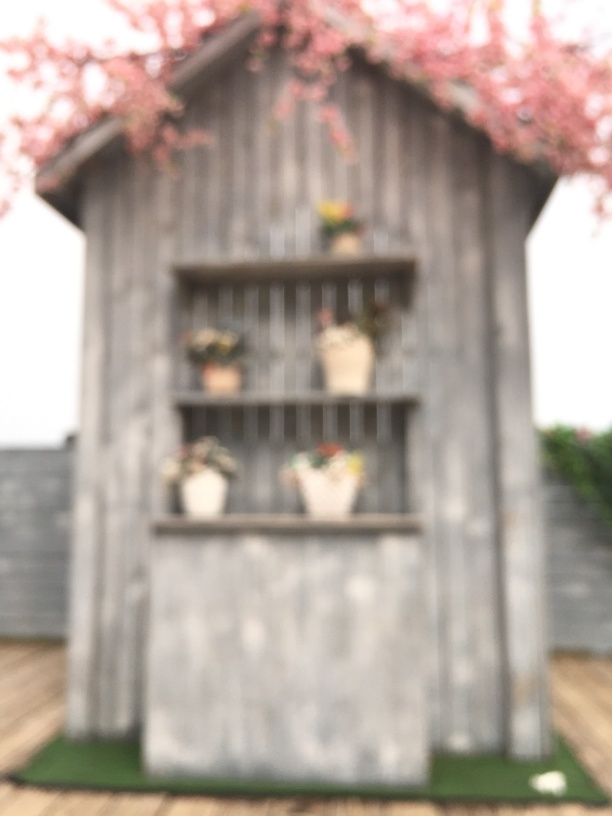Does the image have slight noise?
 Yes 